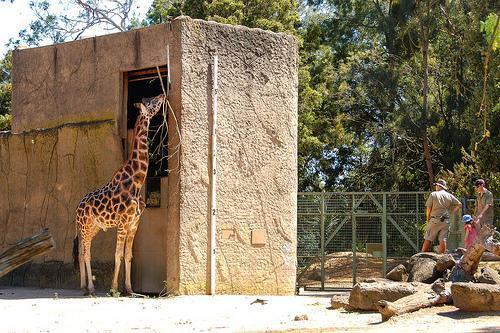How many people?
Give a very brief answer. 3. How many giraffes are there?
Give a very brief answer. 1. 